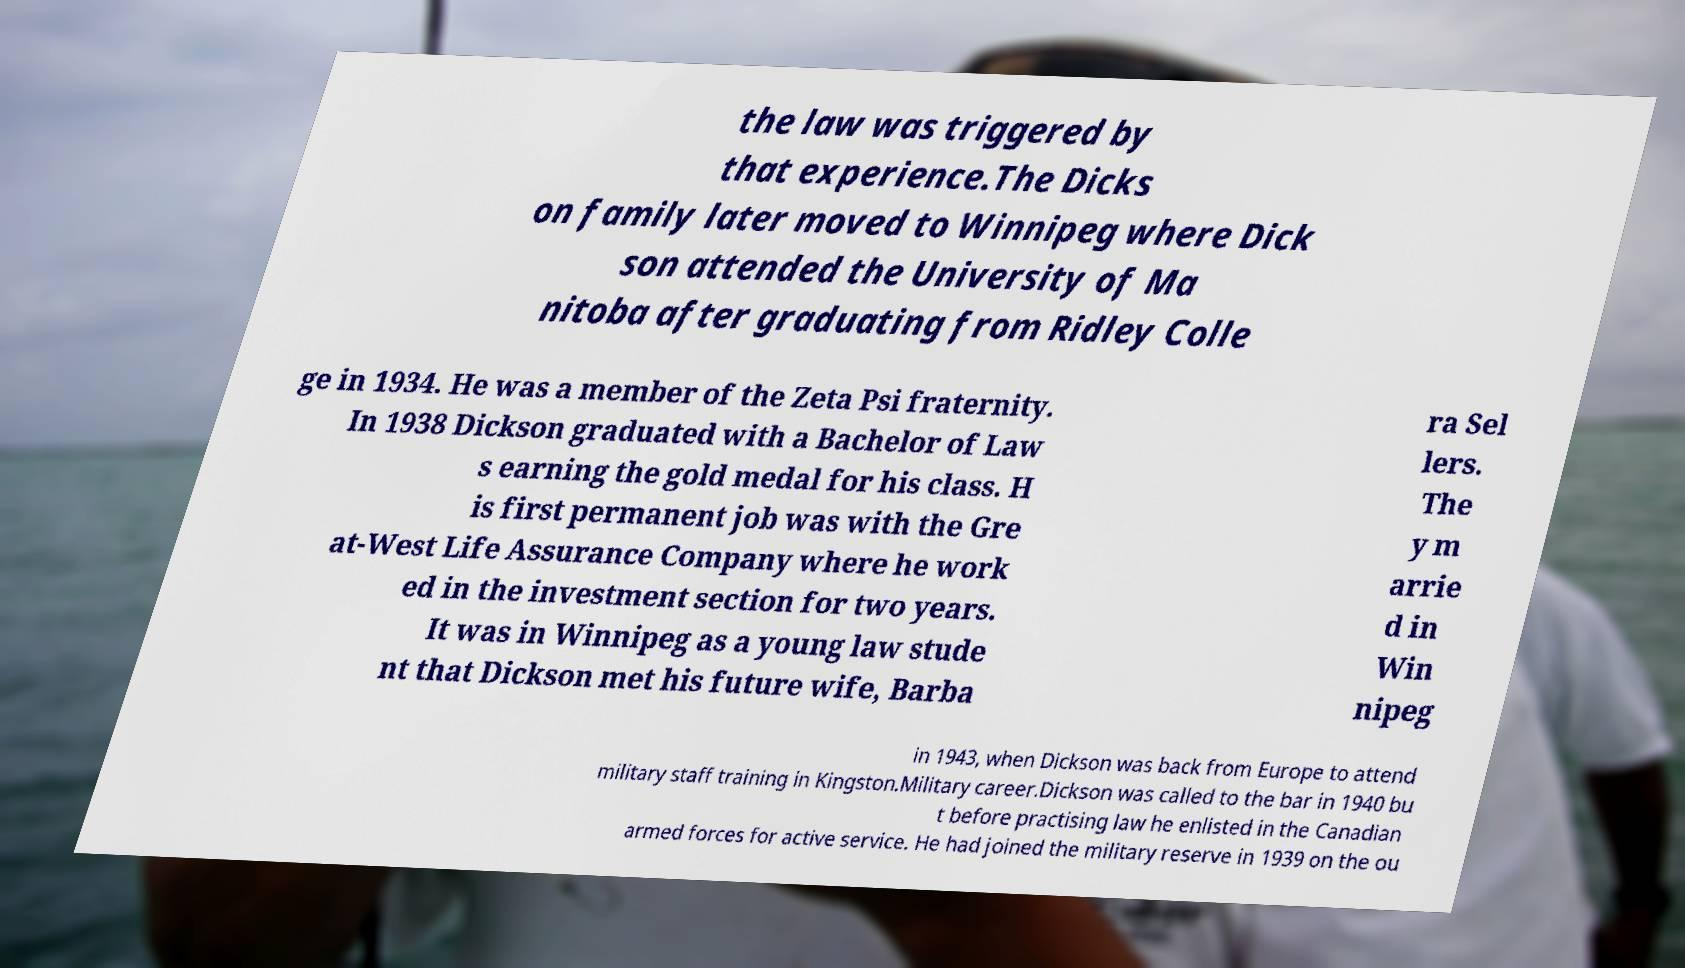Can you accurately transcribe the text from the provided image for me? the law was triggered by that experience.The Dicks on family later moved to Winnipeg where Dick son attended the University of Ma nitoba after graduating from Ridley Colle ge in 1934. He was a member of the Zeta Psi fraternity. In 1938 Dickson graduated with a Bachelor of Law s earning the gold medal for his class. H is first permanent job was with the Gre at-West Life Assurance Company where he work ed in the investment section for two years. It was in Winnipeg as a young law stude nt that Dickson met his future wife, Barba ra Sel lers. The y m arrie d in Win nipeg in 1943, when Dickson was back from Europe to attend military staff training in Kingston.Military career.Dickson was called to the bar in 1940 bu t before practising law he enlisted in the Canadian armed forces for active service. He had joined the military reserve in 1939 on the ou 